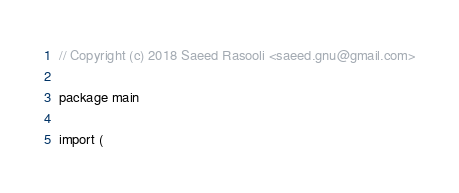Convert code to text. <code><loc_0><loc_0><loc_500><loc_500><_Go_>// Copyright (c) 2018 Saeed Rasooli <saeed.gnu@gmail.com>

package main

import (</code> 